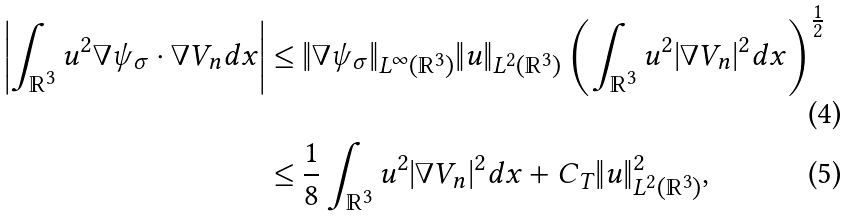Convert formula to latex. <formula><loc_0><loc_0><loc_500><loc_500>\left | \int _ { \mathbb { R } ^ { 3 } } u ^ { 2 } \nabla \psi _ { \sigma } \cdot \nabla V _ { n } d x \right | \leq & \ \| \nabla \psi _ { \sigma } \| _ { L ^ { \infty } ( \mathbb { R } ^ { 3 } ) } \| u \| _ { L ^ { 2 } ( \mathbb { R } ^ { 3 } ) } \left ( \int _ { \mathbb { R } ^ { 3 } } u ^ { 2 } | \nabla V _ { n } | ^ { 2 } d x \right ) ^ { \frac { 1 } { 2 } } \\ \leq & \ \frac { 1 } { 8 } \int _ { \mathbb { R } ^ { 3 } } u ^ { 2 } | \nabla V _ { n } | ^ { 2 } d x + C _ { T } \| u \| ^ { 2 } _ { L ^ { 2 } ( \mathbb { R } ^ { 3 } ) } ,</formula> 